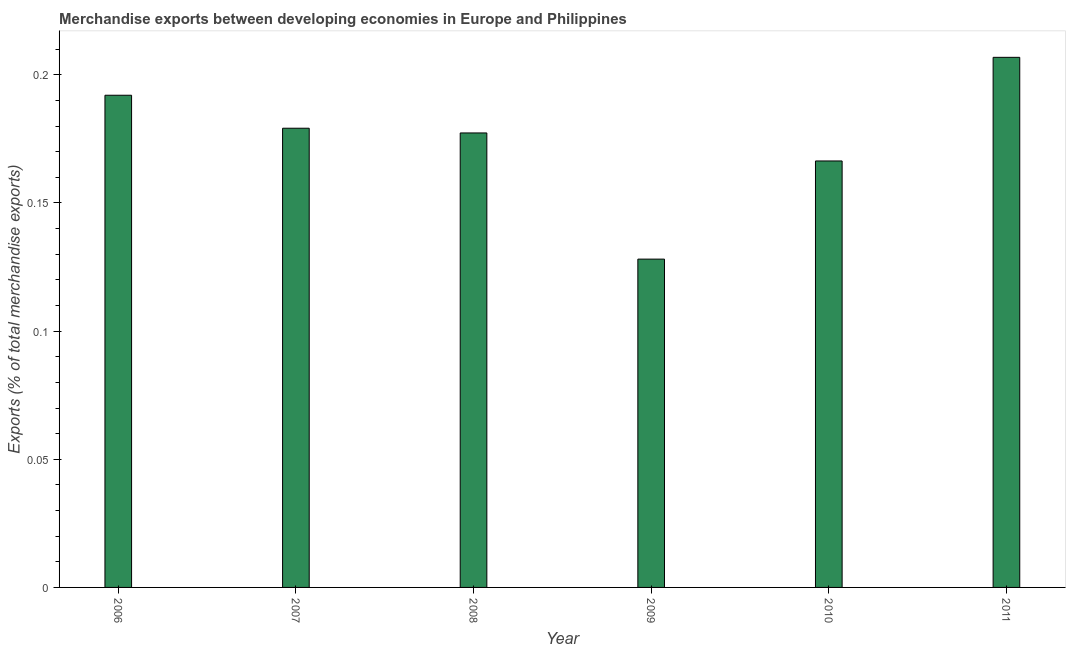Does the graph contain any zero values?
Your answer should be compact. No. Does the graph contain grids?
Keep it short and to the point. No. What is the title of the graph?
Keep it short and to the point. Merchandise exports between developing economies in Europe and Philippines. What is the label or title of the Y-axis?
Make the answer very short. Exports (% of total merchandise exports). What is the merchandise exports in 2006?
Offer a very short reply. 0.19. Across all years, what is the maximum merchandise exports?
Offer a very short reply. 0.21. Across all years, what is the minimum merchandise exports?
Provide a succinct answer. 0.13. In which year was the merchandise exports maximum?
Provide a succinct answer. 2011. What is the sum of the merchandise exports?
Give a very brief answer. 1.05. What is the difference between the merchandise exports in 2007 and 2008?
Ensure brevity in your answer.  0. What is the average merchandise exports per year?
Give a very brief answer. 0.17. What is the median merchandise exports?
Provide a short and direct response. 0.18. In how many years, is the merchandise exports greater than 0.18 %?
Make the answer very short. 2. What is the ratio of the merchandise exports in 2006 to that in 2007?
Provide a short and direct response. 1.07. What is the difference between the highest and the second highest merchandise exports?
Offer a very short reply. 0.01. Is the sum of the merchandise exports in 2006 and 2010 greater than the maximum merchandise exports across all years?
Your answer should be compact. Yes. What is the difference between the highest and the lowest merchandise exports?
Provide a succinct answer. 0.08. What is the Exports (% of total merchandise exports) of 2006?
Offer a very short reply. 0.19. What is the Exports (% of total merchandise exports) of 2007?
Keep it short and to the point. 0.18. What is the Exports (% of total merchandise exports) in 2008?
Your response must be concise. 0.18. What is the Exports (% of total merchandise exports) of 2009?
Your answer should be very brief. 0.13. What is the Exports (% of total merchandise exports) in 2010?
Your answer should be compact. 0.17. What is the Exports (% of total merchandise exports) in 2011?
Offer a very short reply. 0.21. What is the difference between the Exports (% of total merchandise exports) in 2006 and 2007?
Your answer should be compact. 0.01. What is the difference between the Exports (% of total merchandise exports) in 2006 and 2008?
Provide a succinct answer. 0.01. What is the difference between the Exports (% of total merchandise exports) in 2006 and 2009?
Ensure brevity in your answer.  0.06. What is the difference between the Exports (% of total merchandise exports) in 2006 and 2010?
Your answer should be very brief. 0.03. What is the difference between the Exports (% of total merchandise exports) in 2006 and 2011?
Your answer should be very brief. -0.01. What is the difference between the Exports (% of total merchandise exports) in 2007 and 2008?
Your response must be concise. 0. What is the difference between the Exports (% of total merchandise exports) in 2007 and 2009?
Keep it short and to the point. 0.05. What is the difference between the Exports (% of total merchandise exports) in 2007 and 2010?
Offer a very short reply. 0.01. What is the difference between the Exports (% of total merchandise exports) in 2007 and 2011?
Your response must be concise. -0.03. What is the difference between the Exports (% of total merchandise exports) in 2008 and 2009?
Give a very brief answer. 0.05. What is the difference between the Exports (% of total merchandise exports) in 2008 and 2010?
Provide a short and direct response. 0.01. What is the difference between the Exports (% of total merchandise exports) in 2008 and 2011?
Provide a succinct answer. -0.03. What is the difference between the Exports (% of total merchandise exports) in 2009 and 2010?
Give a very brief answer. -0.04. What is the difference between the Exports (% of total merchandise exports) in 2009 and 2011?
Keep it short and to the point. -0.08. What is the difference between the Exports (% of total merchandise exports) in 2010 and 2011?
Your answer should be very brief. -0.04. What is the ratio of the Exports (% of total merchandise exports) in 2006 to that in 2007?
Your answer should be very brief. 1.07. What is the ratio of the Exports (% of total merchandise exports) in 2006 to that in 2008?
Provide a succinct answer. 1.08. What is the ratio of the Exports (% of total merchandise exports) in 2006 to that in 2009?
Make the answer very short. 1.5. What is the ratio of the Exports (% of total merchandise exports) in 2006 to that in 2010?
Offer a very short reply. 1.15. What is the ratio of the Exports (% of total merchandise exports) in 2006 to that in 2011?
Offer a very short reply. 0.93. What is the ratio of the Exports (% of total merchandise exports) in 2007 to that in 2009?
Offer a terse response. 1.4. What is the ratio of the Exports (% of total merchandise exports) in 2007 to that in 2010?
Keep it short and to the point. 1.08. What is the ratio of the Exports (% of total merchandise exports) in 2007 to that in 2011?
Your answer should be very brief. 0.87. What is the ratio of the Exports (% of total merchandise exports) in 2008 to that in 2009?
Give a very brief answer. 1.38. What is the ratio of the Exports (% of total merchandise exports) in 2008 to that in 2010?
Your answer should be very brief. 1.07. What is the ratio of the Exports (% of total merchandise exports) in 2008 to that in 2011?
Your answer should be compact. 0.86. What is the ratio of the Exports (% of total merchandise exports) in 2009 to that in 2010?
Provide a short and direct response. 0.77. What is the ratio of the Exports (% of total merchandise exports) in 2009 to that in 2011?
Offer a very short reply. 0.62. What is the ratio of the Exports (% of total merchandise exports) in 2010 to that in 2011?
Offer a terse response. 0.8. 